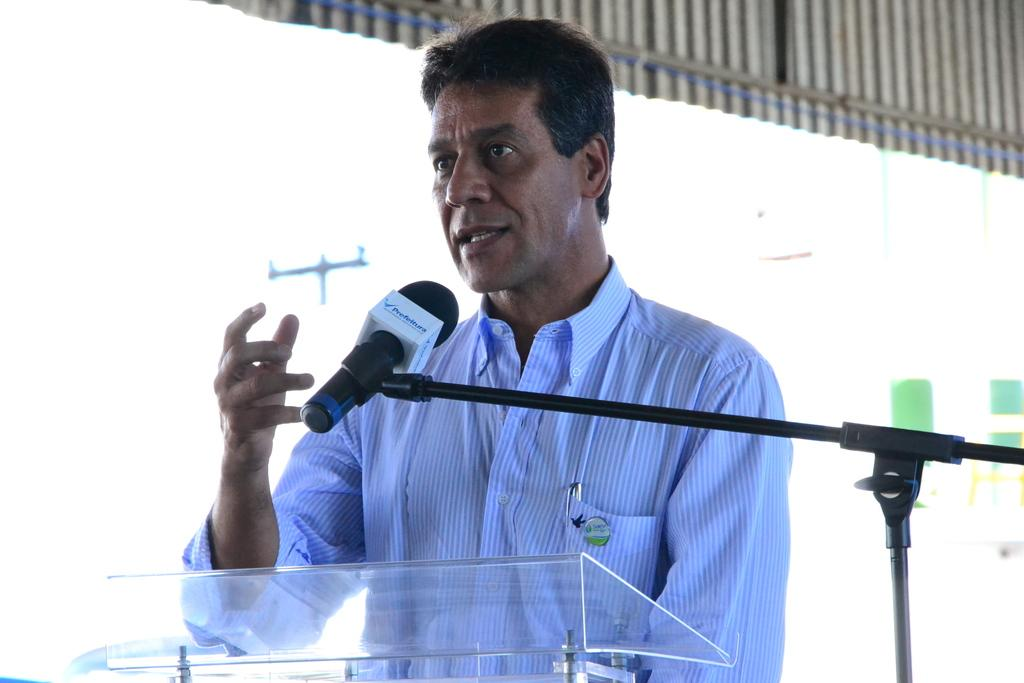What is located at the bottom of the image? There is a podium at the bottom of the image. What is on the podium? There is a microphone at the podium. Who is standing near the podium? A man is standing behind the podium. What is visible at the top of the image? There is a roof visible at the top of the image. What is the temperature of the man standing behind the podium in the image? The temperature of the man cannot be determined from the image. How does the man control the microphone at the podium in the image? The image does not show the man controlling the microphone, so it cannot be determined from the image. 